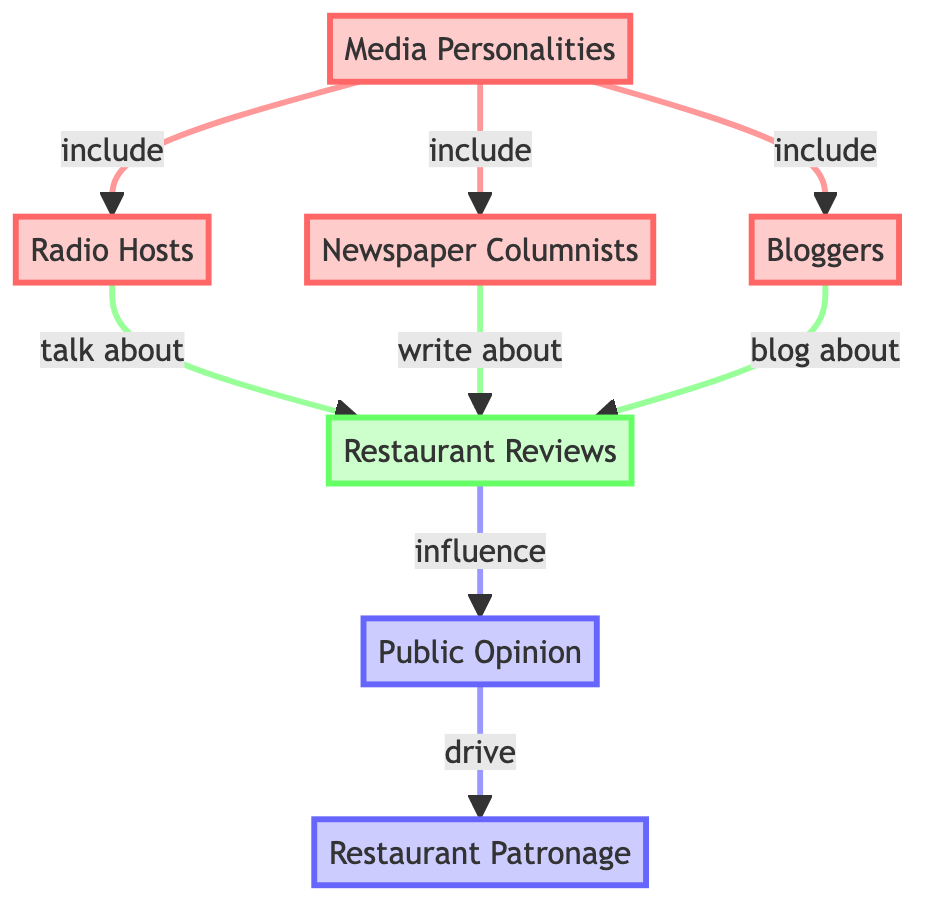What are the nodes included under Media Personalities? The diagram shows that Media Personalities include the nodes Radio Hosts, Newspaper Columnists, and Bloggers. Each of these nodes is directly connected to the Media Personalities node, indicating they are subsets of it.
Answer: Radio Hosts, Newspaper Columnists, Bloggers How many types of media personalities are present in the diagram? The diagram lists three distinct types of media personalities: Radio Hosts, Newspaper Columnists, and Bloggers. Each type is represented by a separate node directly under the Media Personalities node.
Answer: 3 What influences Public Opinion in this diagram? According to the diagram, Public Opinion is influenced by Restaurant Reviews. The flow from Restaurant Reviews to Public Opinion indicates that reviews impact how the public perceives restaurants.
Answer: Restaurant Reviews Which media personality type talks about Restaurant Reviews? The diagram specifies that Radio Hosts talk about Restaurant Reviews. There is a direct connection from the Radio Hosts node to the Restaurant Reviews node, indicating this relationship.
Answer: Radio Hosts How does Public Opinion affect Restaurant Patronage? The diagram illustrates that Public Opinion drives Restaurant Patronage. This means changes or trends in public opinion can directly lead to increased or decreased patronage at restaurants.
Answer: Drives What is the relationship between Bloggers and Restaurant Reviews? The diagram indicates that Bloggers blog about Restaurant Reviews. This shows a distinct relationship where bloggers contribute their thoughts and opinions regarding restaurants through their blogs, thus influencing restaurant reviews.
Answer: Blog about Which type of media personality has the relationship labeled "write about"? The diagram shows that Newspaper Columnists have the relationship labeled "write about" in relation to Restaurant Reviews. There is a direct connection from the Newspaper Columnists node to the Restaurant Reviews node confirming this.
Answer: Newspaper Columnists How many total edges are visible in the diagram? The diagram contains a series of directed connections (edges) between the nodes. By counting each connection, we can see there are a total of seven edges in the diagram itself.
Answer: 7 What flows from Restaurant Reviews to Public Opinion? The diagram clearly indicates that Restaurant Reviews influence Public Opinion. This directional relationship signifies that the reviews impact how the public views various restaurants.
Answer: Influence 